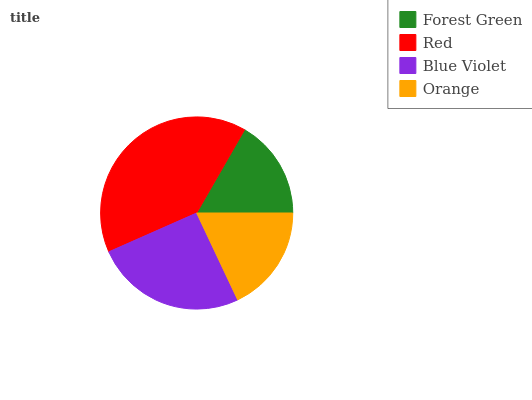Is Forest Green the minimum?
Answer yes or no. Yes. Is Red the maximum?
Answer yes or no. Yes. Is Blue Violet the minimum?
Answer yes or no. No. Is Blue Violet the maximum?
Answer yes or no. No. Is Red greater than Blue Violet?
Answer yes or no. Yes. Is Blue Violet less than Red?
Answer yes or no. Yes. Is Blue Violet greater than Red?
Answer yes or no. No. Is Red less than Blue Violet?
Answer yes or no. No. Is Blue Violet the high median?
Answer yes or no. Yes. Is Orange the low median?
Answer yes or no. Yes. Is Red the high median?
Answer yes or no. No. Is Red the low median?
Answer yes or no. No. 